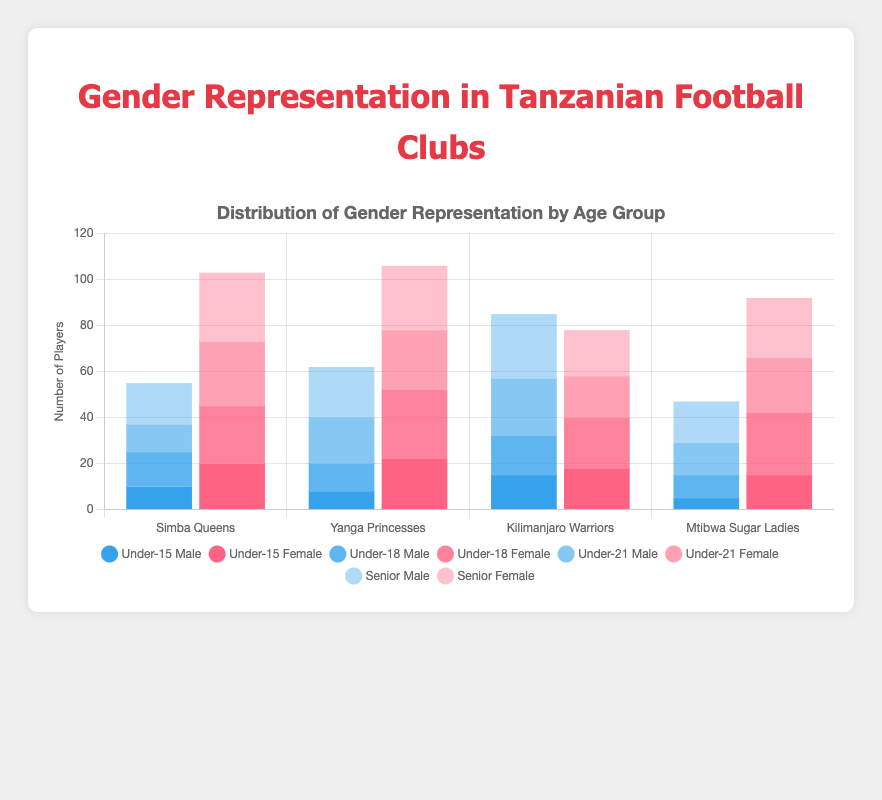What is the total number of female players in the "Senior" age group across all clubs? Sum up the number of female players in the "Senior" age group for each club. Simba Queens has 30, Yanga Princesses has 28, Kilimanjaro Warriors has 20, and Mtibwa Sugar Ladies has 26. So, the total is 30 + 28 + 20 + 26 = 104.
Answer: 104 Which club has the highest number of male players in the "Under-21" age group? Compare the number of male players in the "Under-21" age group for each club. Simba Queens has 12, Yanga Princesses has 20, Kilimanjaro Warriors has 25, and Mtibwa Sugar Ladies has 14. Kilimanjaro Warriors has the highest number with 25.
Answer: Kilimanjaro Warriors Which age group shows the highest combined number of players in Simba Queens? Add the number of male and female players in each age group for Simba Queens. Under-15: 10 + 20 = 30, Under-18: 15 + 25 = 40, Under-21: 12 + 28 = 40, Senior: 18 + 30 = 48. The "Senior" age group has the highest combined number with 48.
Answer: Senior What color represents the female players in the "Under-18" age group? The visual attribute "color" for "Under-18" female players is indicated in the figure. The bars for "Under-18" female players are represented in a pinkish-red color.
Answer: Pinkish-red How does the number of male players in the "Under-18" age group for Kilimanjaro Warriors compare to Simba Queens? Identify the number of male players in the "Under-18" age group for both clubs. Kilimanjaro Warriors has 17 and Simba Queens has 15. Kilimanjaro Warriors has more male players by 2.
Answer: Kilimanjaro Warriors has more by 2 Which club has the lowest number of female players in any age group? Examine the female player counts in each age group for all clubs. Mtibwa Sugar Ladies has the lowest number of female players in the "Under-15" age group with 15.
Answer: Mtibwa Sugar Ladies What is the total number of players in the "Under-18" age group across all clubs? Sum up the total number of players (male + female) in the "Under-18" age group for each club. Simba Queens has 15 + 25 = 40, Yanga Princesses has 12 + 30 = 42, Kilimanjaro Warriors has 17 + 22 = 39, and Mtibwa Sugar Ladies has 10 + 27 = 37. The total is 40 + 42 + 39 + 37 = 158.
Answer: 158 